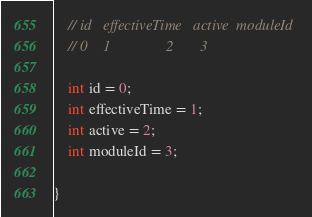Convert code to text. <code><loc_0><loc_0><loc_500><loc_500><_Java_>	// id	effectiveTime	active	moduleId
	// 0	1				2		3

	int id = 0;
	int effectiveTime = 1;
	int active = 2;
	int moduleId = 3;

}
</code> 